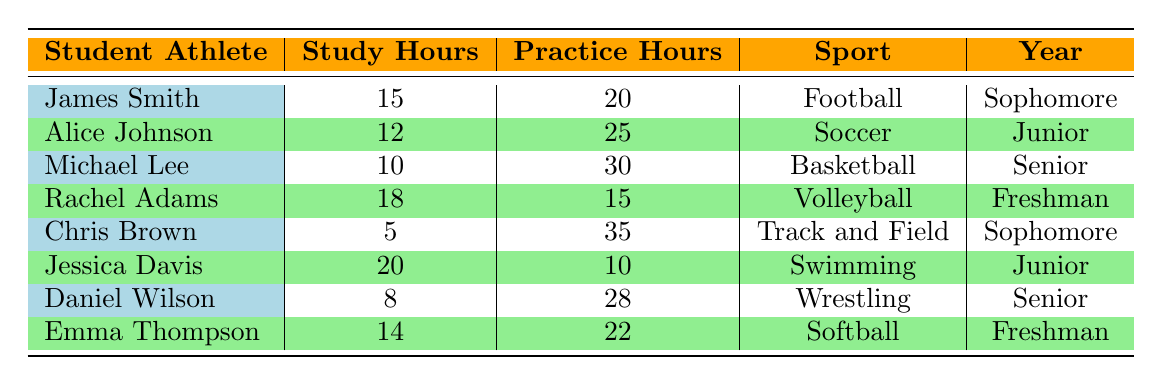What is the maximum practice hours recorded in the table? The maximum value in the 'Practice Hours' column is 35, which is associated with Chris Brown.
Answer: 35 Who is the student athlete with the highest study hours? Rachel Adams has the highest study hours at 18 hours among the student athletes listed.
Answer: Rachel Adams What is the difference between the highest and lowest study hours? The highest study hours is 20 (Jessica Davis) and the lowest is 5 (Chris Brown). The difference is 20 - 5 = 15.
Answer: 15 Is there a junior student athlete who practices less than 20 hours? Alice Johnson, a junior, practices for 25 hours, and Jessica Davis practices for 10 hours. Therefore, yes, Jessica Davis practices less than 20 hours.
Answer: Yes What is the average number of practice hours for all the student athletes? First, we sum all practice hours: 20 + 25 + 30 + 15 + 35 + 10 + 28 + 22 =  10 + 25 + 30 + 15 + 35 + 10 + 28 + 22 =  20 + 30 + 35 + 24 + 30 + 28 + 12 = 30 + 35 + 68 = 128. We have 8 data points, so the average is 220/8 = 19.
Answer: 19 Which sport has the student athlete with the least study hours? Chris Brown, who is in Track and Field, has the least study hours at 5 hours compared to the others.
Answer: Track and Field Are there more students in their freshman year or junior year? Rachel Adams and Emma Thompson are freshmen while Alice Johnson and Jessica Davis are juniors. Thus, there are two freshmen and two juniors, so the numbers are equal.
Answer: No What is the median practice hours of all the student athletes? The practice hours sorted are: 10, 15, 20, 22, 25, 28, 30, 35. Since there are 8 values, we take the average of the 4th and 5th values, which are 22 and 25: (22 + 25) / 2 = 23.5.
Answer: 23.5 Which student athlete spends more time practicing than studying? Chris Brown (5 study hours, 35 practice hours), Michael Lee (10 study hours, 30 practice hours), and Daniel Wilson (8 study hours, 28 practice hours) are all athletes who practice more than they study.
Answer: Chris Brown, Michael Lee, Daniel Wilson 